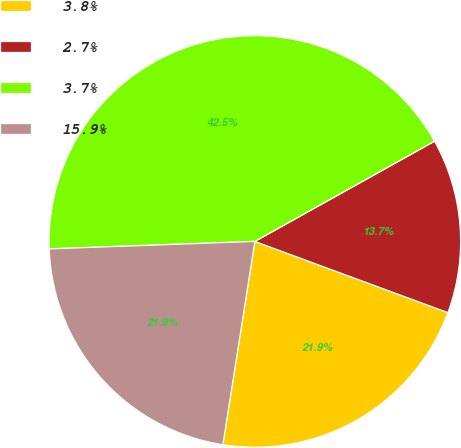<chart> <loc_0><loc_0><loc_500><loc_500><pie_chart><fcel>3.8%<fcel>2.7%<fcel>3.7%<fcel>15.9%<nl><fcel>21.86%<fcel>13.72%<fcel>42.48%<fcel>21.94%<nl></chart> 